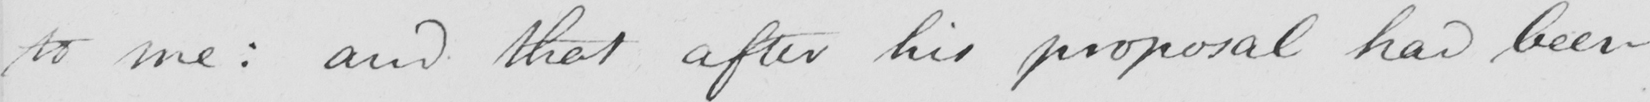Can you tell me what this handwritten text says? to me :  and that after his proposal had been 